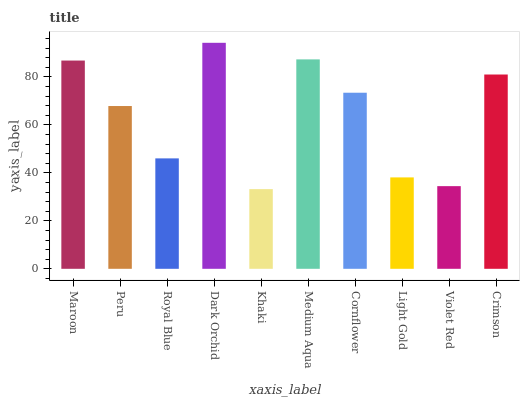Is Khaki the minimum?
Answer yes or no. Yes. Is Dark Orchid the maximum?
Answer yes or no. Yes. Is Peru the minimum?
Answer yes or no. No. Is Peru the maximum?
Answer yes or no. No. Is Maroon greater than Peru?
Answer yes or no. Yes. Is Peru less than Maroon?
Answer yes or no. Yes. Is Peru greater than Maroon?
Answer yes or no. No. Is Maroon less than Peru?
Answer yes or no. No. Is Cornflower the high median?
Answer yes or no. Yes. Is Peru the low median?
Answer yes or no. Yes. Is Violet Red the high median?
Answer yes or no. No. Is Khaki the low median?
Answer yes or no. No. 